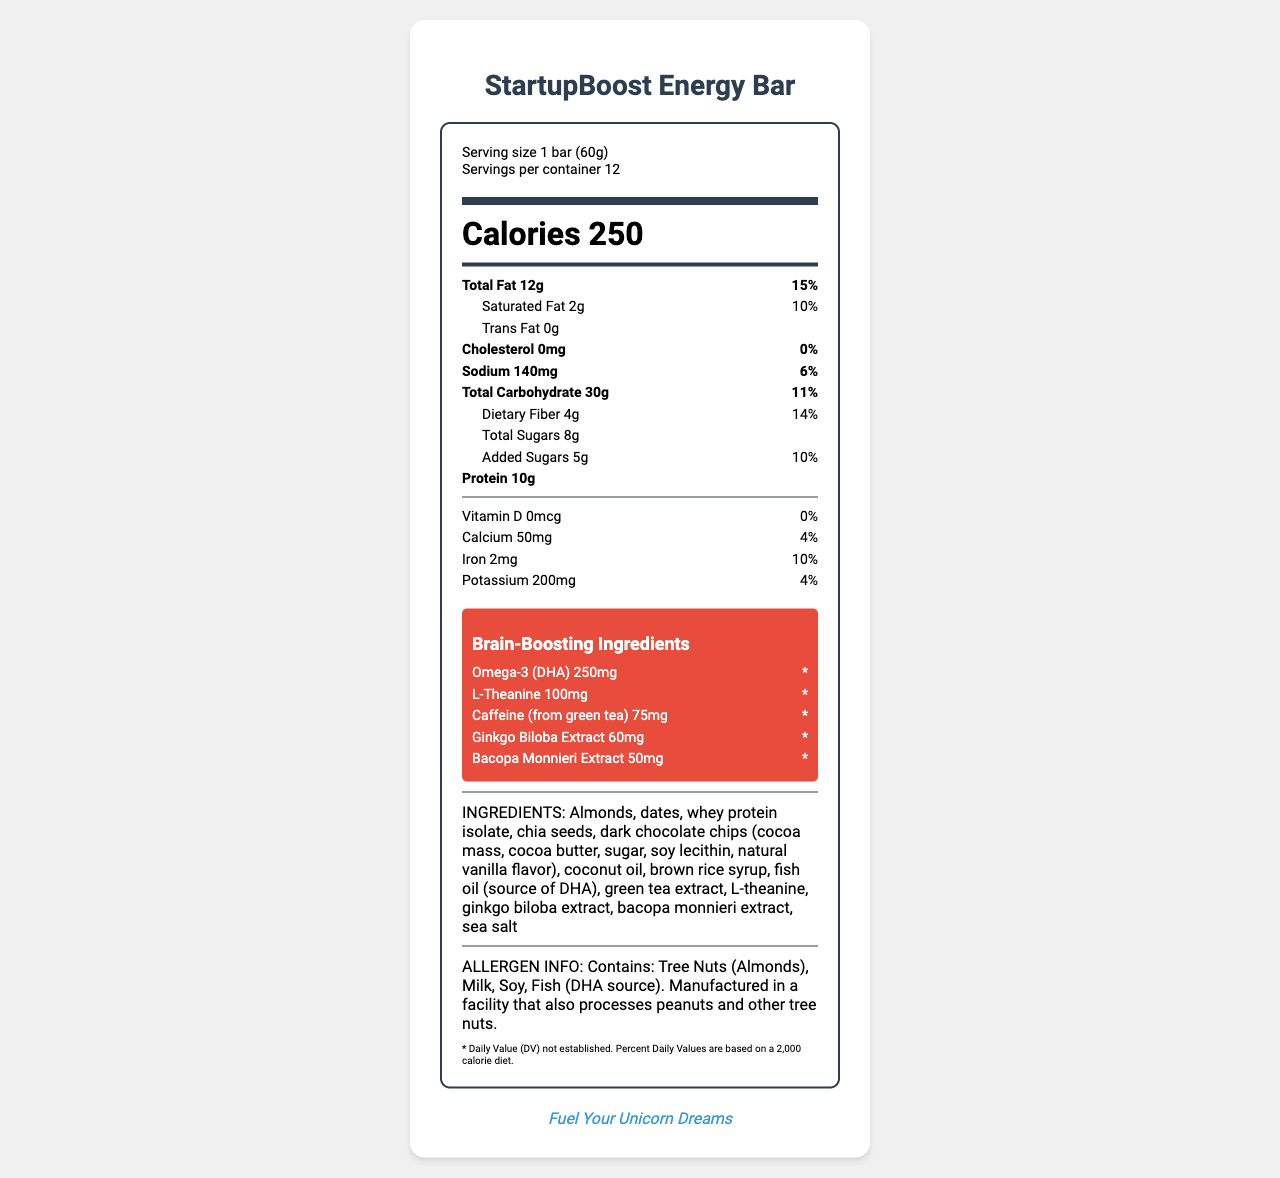what is the serving size of the StartupBoost Energy Bar? The serving size information is mentioned under the serving info section at the top.
Answer: 1 bar (60g) how many calories are in one serving of the StartupBoost Energy Bar? The calorie count per serving is displayed prominently under the "Calories" heading.
Answer: 250 what is the total carbohydrate content per serving? The total carbohydrate content is listed under the nutrient section and shows 30g.
Answer: 30g how much protein does one bar contain? The protein content is listed in the nutrients section of the document.
Answer: 10g what are the added sugars in one serving of the bar? The amount of added sugars is displayed as "Added Sugars 5g" in the indent under the total sugars line.
Answer: 5g which brain-boosting ingredient is present in the highest amount, and how much is it? The brain-boosting section lists Omega-3 (DHA) with an amount of 250mg, which is the highest among the listed brain-boosting ingredients.
Answer: Omega-3 (DHA) 250mg which of the following ingredients are present in the bar? A. Almonds B. Dates C. Honey D. Brown Rice Syrup Ingredients section lists Almonds, Dates, and Brown Rice Syrup, but not Honey.
Answer: A, B, D how much iron is in one serving? A. 1mg B. 2mg C. 3mg D. 4mg The iron content per serving is mentioned as 2mg.
Answer: B is the bar cholesterol-free? The document states "Cholesterol 0mg" indicating it's cholesterol-free.
Answer: Yes what is the main idea of the document? The document is a nutrition facts label for the StartupBoost Energy Bar, highlighting its nutritional values and special ingredients geared towards brain health and maintaining an active lifestyle.
Answer: The document provides detailed nutritional information about the StartupBoost Energy Bar, including serving size, nutrient content, allergen information, and brain-boosting ingredients. what is the source of caffeine in this energy bar? The ingredients section lists "green tea extract" as the source of caffeine.
Answer: Green tea does the document state the daily value percentage for Omega-3 (DHA)? The document indicates that the daily value (DV) is not established for Omega-3 (DHA).
Answer: No can it be determined how many grams of protein are recommended daily from the document? The document does not provide any recommended daily values for protein.
Answer: Cannot be determined what allergens are mentioned in the document? The allergen information section lists Tree Nuts (Almonds), Milk, Soy, and Fish (from the DHA source) as allergens contained in the product.
Answer: Tree Nuts (Almonds), Milk, Soy, Fish (DHA source) what is the tagline associated with the StartupBoost Energy Bar? The startup-inspired tagline section at the bottom of the document states "Fuel Your Unicorn Dreams".
Answer: Fuel Your Unicorn Dreams what is the total fat content and its daily value percentage? The total fat content is listed as 12g and the daily value percentage is 15%.
Answer: 12g, 15% 